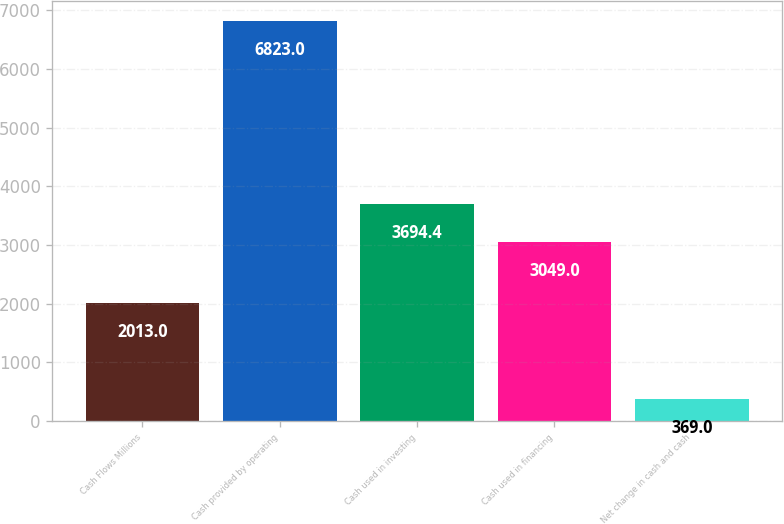Convert chart. <chart><loc_0><loc_0><loc_500><loc_500><bar_chart><fcel>Cash Flows Millions<fcel>Cash provided by operating<fcel>Cash used in investing<fcel>Cash used in financing<fcel>Net change in cash and cash<nl><fcel>2013<fcel>6823<fcel>3694.4<fcel>3049<fcel>369<nl></chart> 